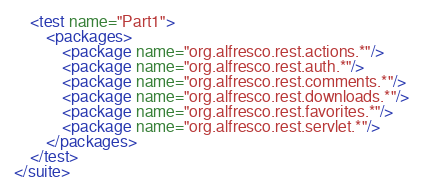<code> <loc_0><loc_0><loc_500><loc_500><_XML_>    <test name="Part1">
        <packages>
            <package name="org.alfresco.rest.actions.*"/>
            <package name="org.alfresco.rest.auth.*"/>
            <package name="org.alfresco.rest.comments.*"/>
            <package name="org.alfresco.rest.downloads.*"/>
            <package name="org.alfresco.rest.favorites.*"/>
            <package name="org.alfresco.rest.servlet.*"/>
        </packages>
    </test>
</suite>
</code> 